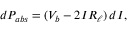<formula> <loc_0><loc_0><loc_500><loc_500>d P _ { a b s } = ( V _ { b } - 2 I R _ { \ell } ) d I ,</formula> 